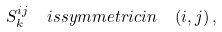<formula> <loc_0><loc_0><loc_500><loc_500>S ^ { i j } _ { k } \ \ i s s y m m e t r i c i n \ \ ( i , j ) \, ,</formula> 